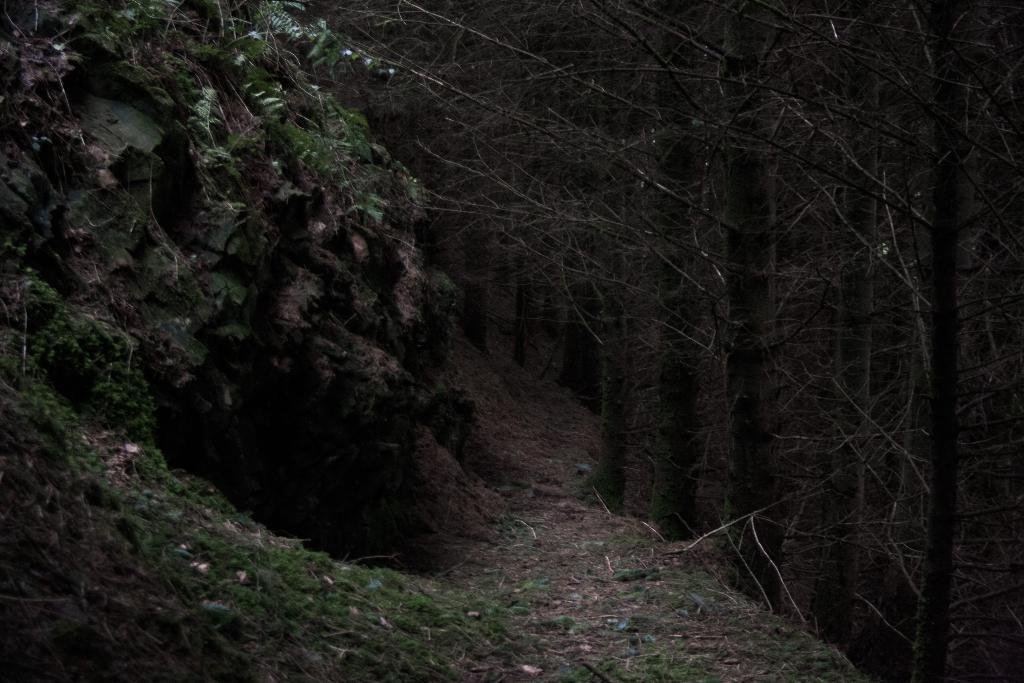What type of terrain is featured in the image? There is a rock slope in the image. Are there any plants visible on the rock slope? Yes, the rock slope has plants on it. What other natural elements can be seen near the rock slope? There are trees beside the rock slope. Can you tell me how many rods are tied in a knot on the rock slope? There are no rods or knots present on the rock slope in the image. 